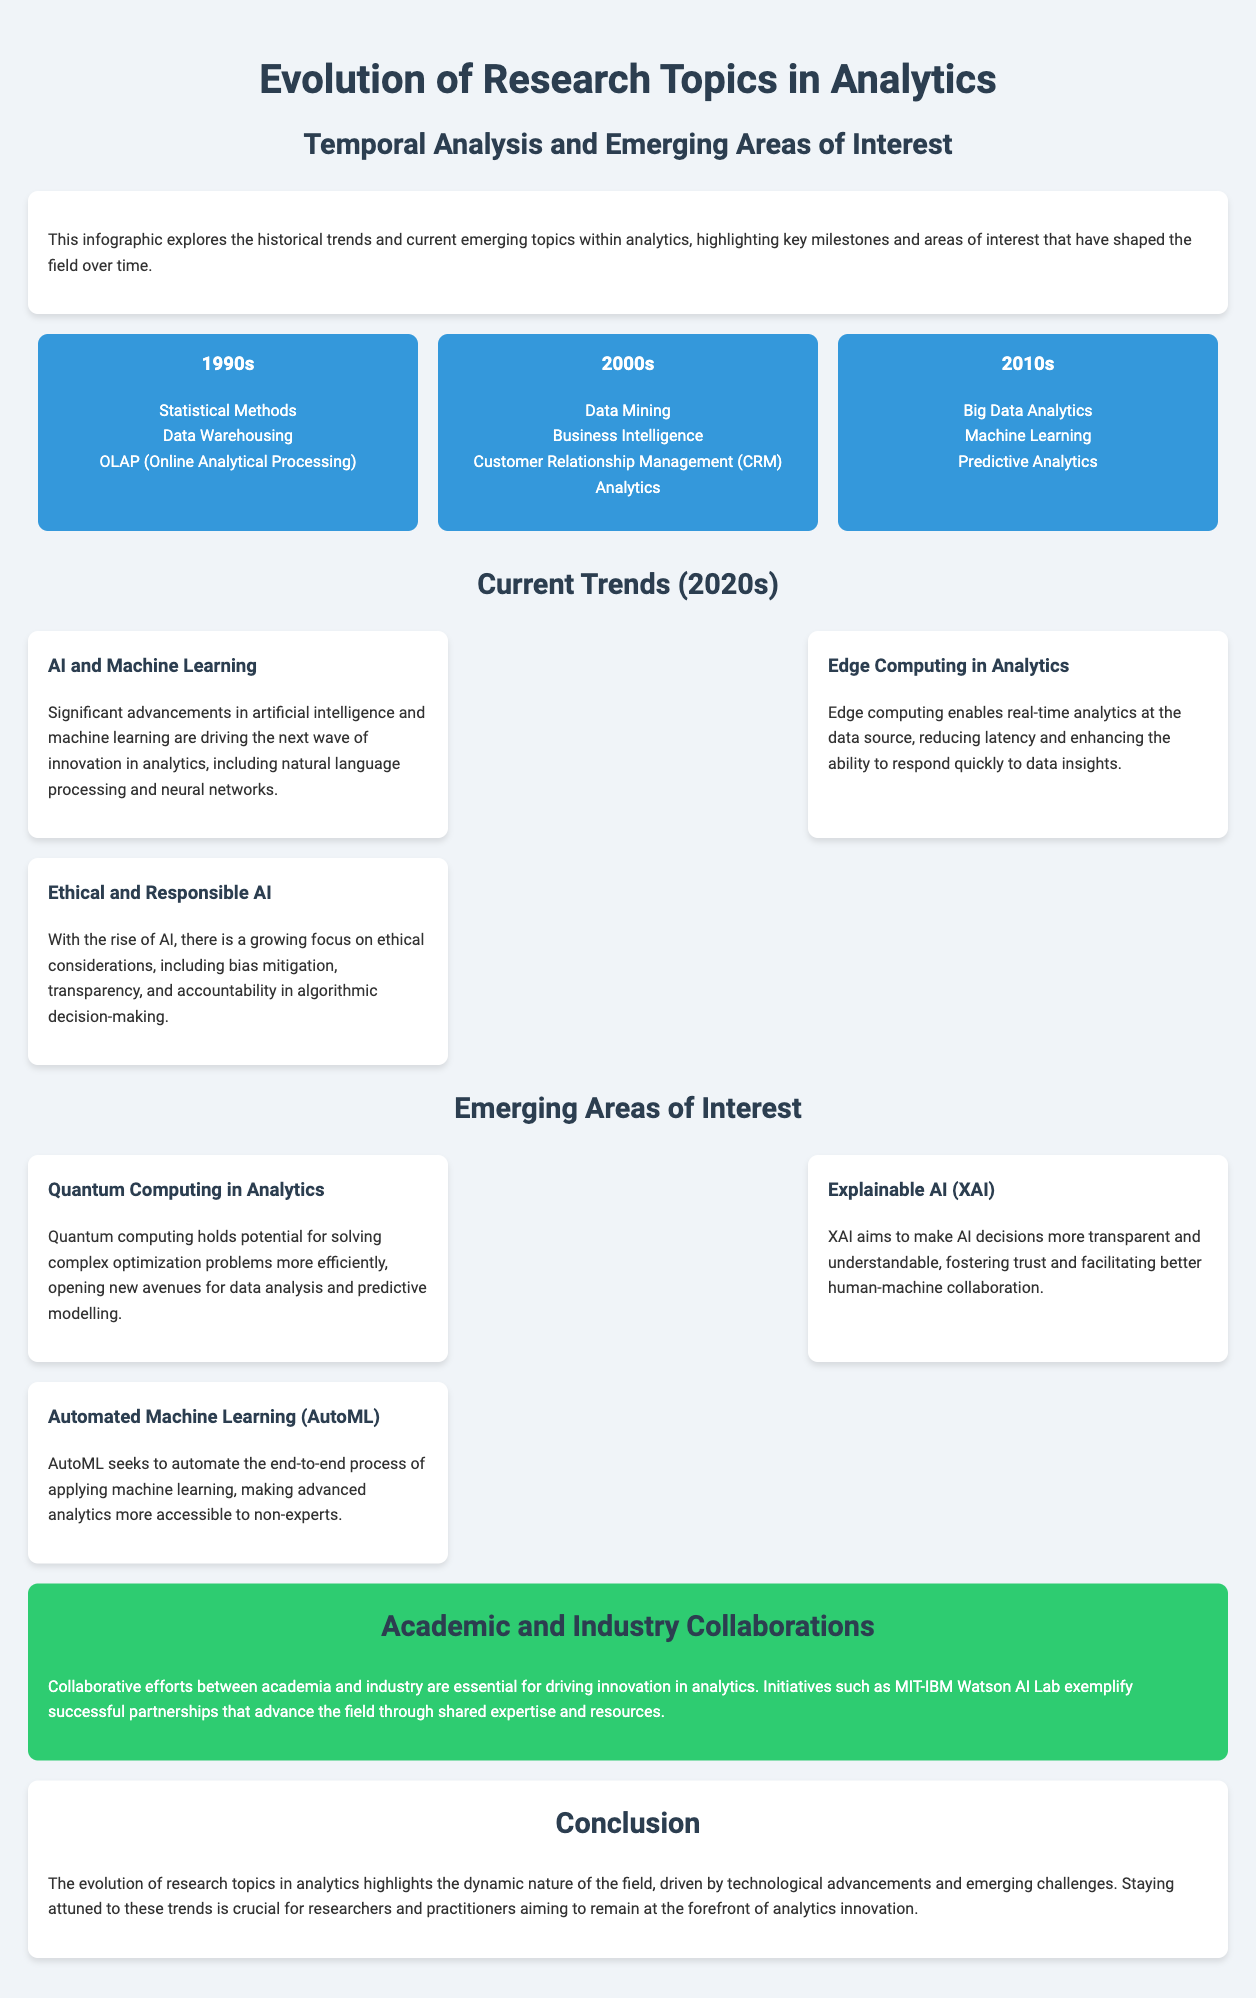What are the key topics from the 1990s? The document lists three key topics from the 1990s in analytics: Statistical Methods, Data Warehousing, and OLAP.
Answer: Statistical Methods, Data Warehousing, OLAP What major advancements are driving current trends? The infographic states that significant advancements in artificial intelligence and machine learning are driving the next wave of innovation in analytics.
Answer: AI and Machine Learning Which emerging area focuses on transparency in AI? The document mentions Explainable AI (XAI) as an emerging area that aims to make AI decisions more transparent and understandable.
Answer: Explainable AI (XAI) How many timeline segments are shown in the document? The infographic contains three timeline segments covering the 1990s, 2000s, and 2010s.
Answer: Three What is an essential aspect of academic and industry collaborations? According to the document, collaborative efforts are essential for driving innovation in analytics.
Answer: Innovation What technology is highlighted for solving complex optimization problems? The infographic identifies Quantum Computing in Analytics as a technology with potential for solving complex optimization problems more efficiently.
Answer: Quantum Computing What decade introduced Big Data Analytics as a research topic? The timeline in the document shows that Big Data Analytics was introduced in the 2010s.
Answer: 2010s What recent trend enhances real-time analytics? The document highlights Edge Computing in Analytics as a recent trend that enables real-time analytics at the data source.
Answer: Edge Computing What is the conclusion of the infographic? The document concludes that the evolution of research topics in analytics highlights the dynamic nature of the field, driven by technological advancements and emerging challenges.
Answer: Dynamic nature of the field 